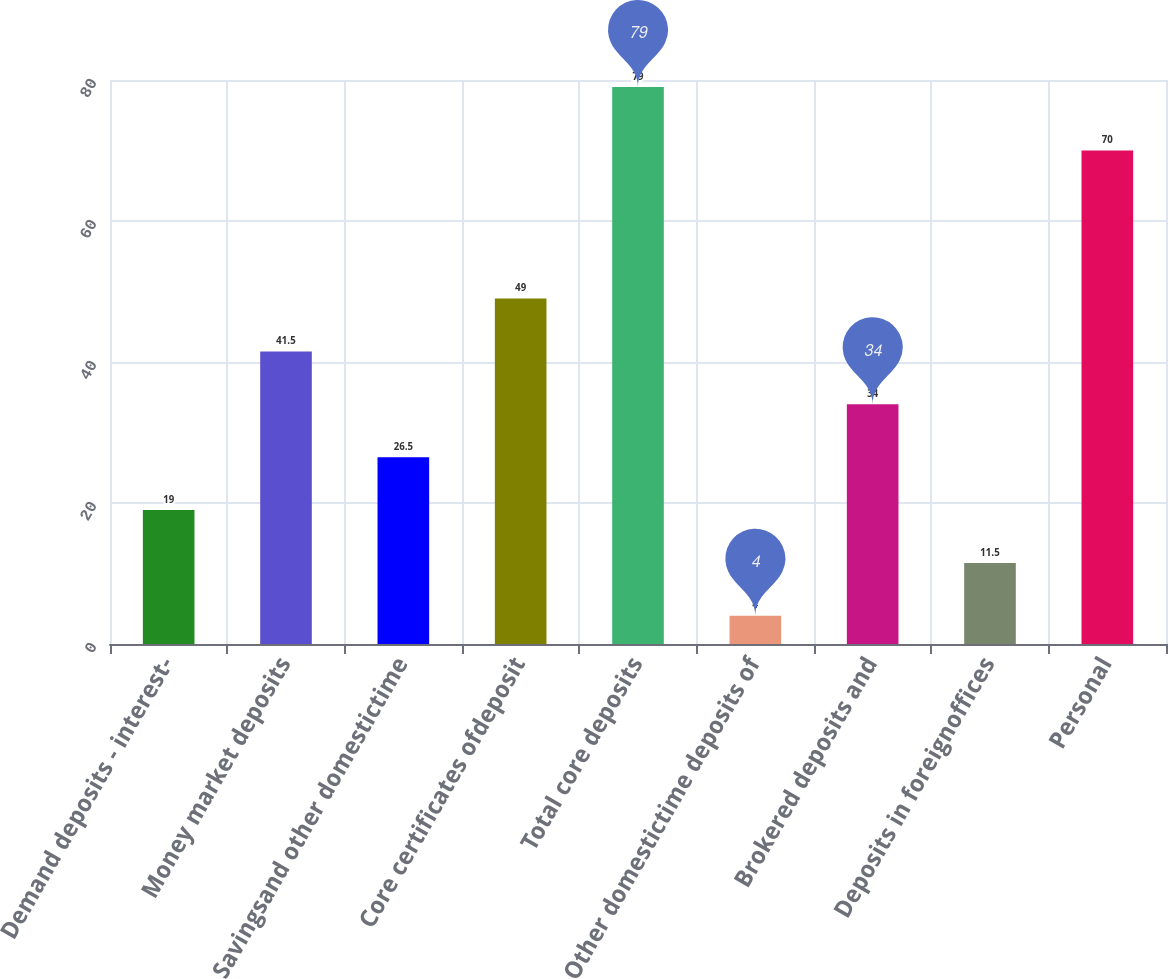<chart> <loc_0><loc_0><loc_500><loc_500><bar_chart><fcel>Demand deposits - interest-<fcel>Money market deposits<fcel>Savingsand other domestictime<fcel>Core certificates ofdeposit<fcel>Total core deposits<fcel>Other domestictime deposits of<fcel>Brokered deposits and<fcel>Deposits in foreignoffices<fcel>Personal<nl><fcel>19<fcel>41.5<fcel>26.5<fcel>49<fcel>79<fcel>4<fcel>34<fcel>11.5<fcel>70<nl></chart> 